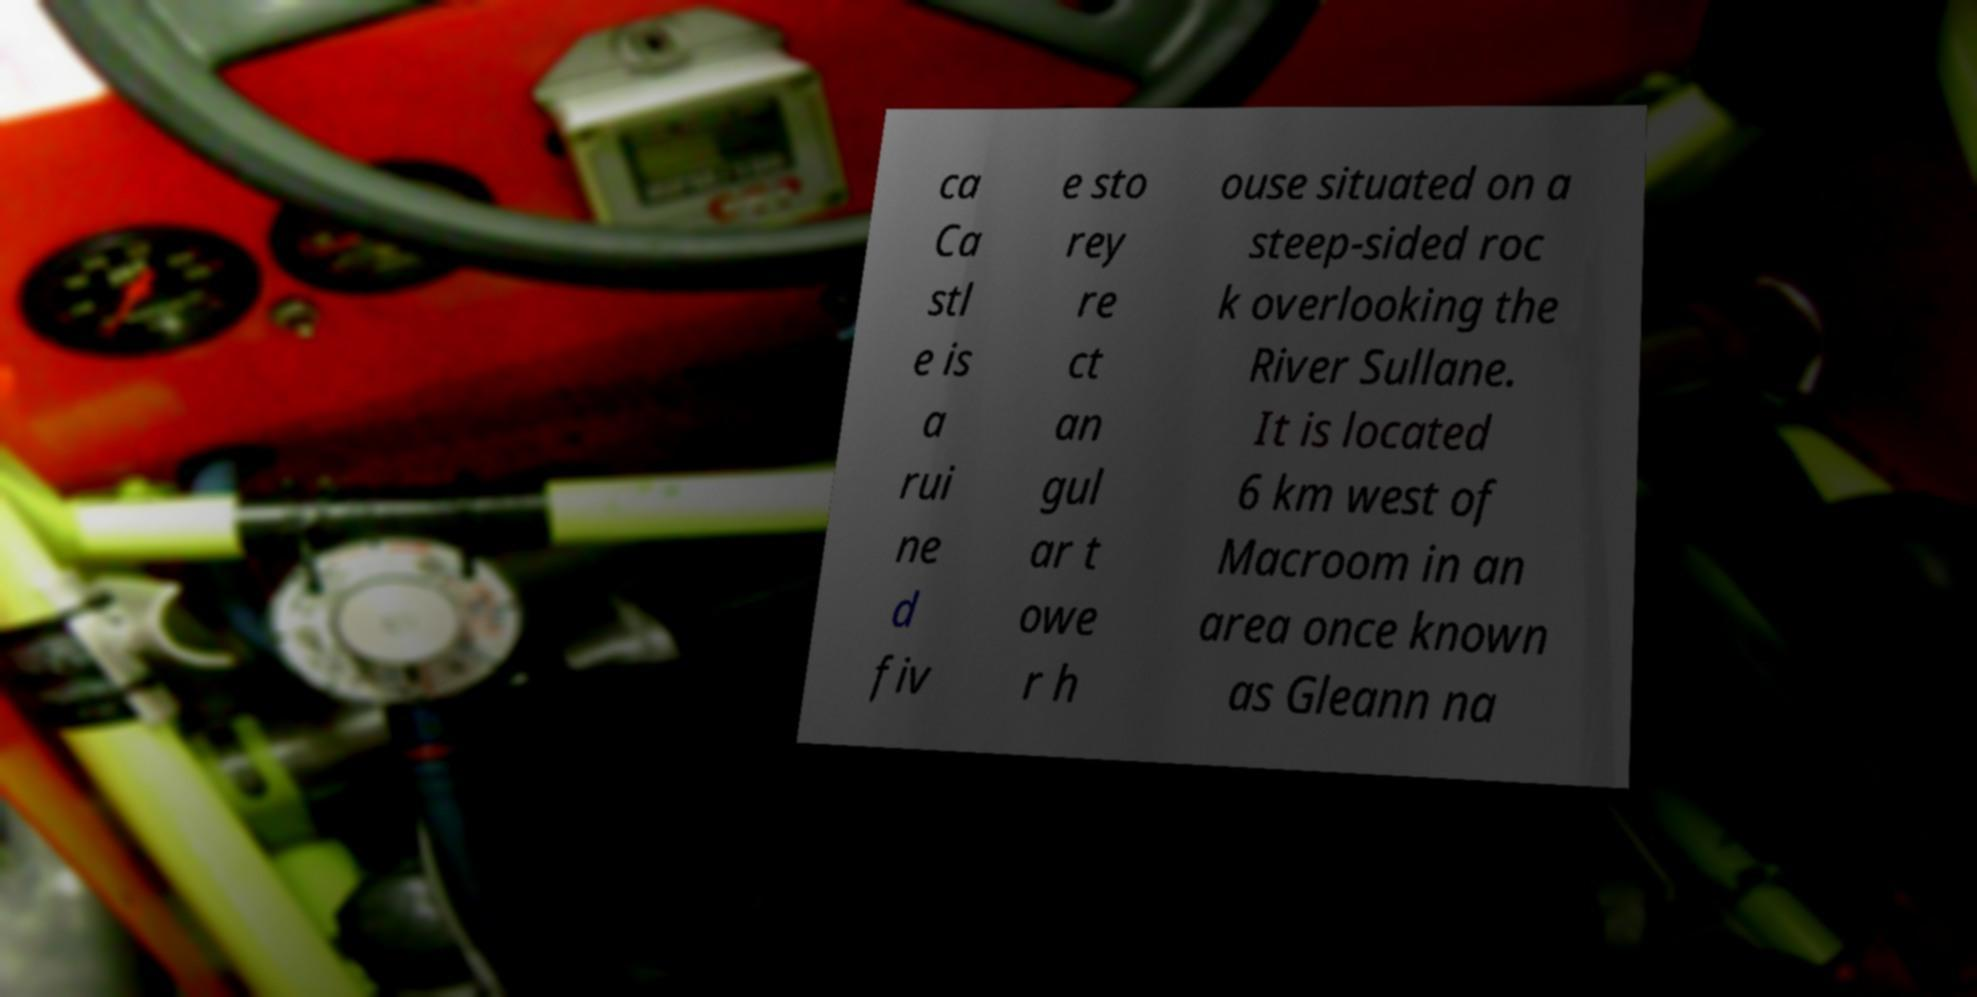There's text embedded in this image that I need extracted. Can you transcribe it verbatim? ca Ca stl e is a rui ne d fiv e sto rey re ct an gul ar t owe r h ouse situated on a steep-sided roc k overlooking the River Sullane. It is located 6 km west of Macroom in an area once known as Gleann na 